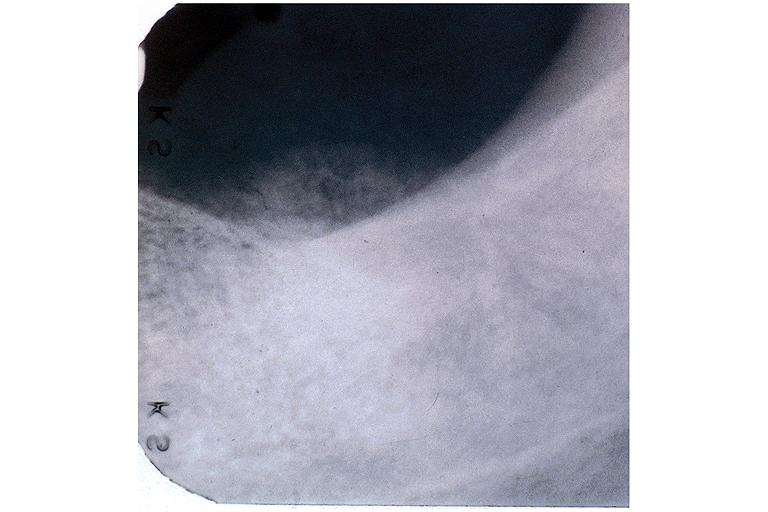s vasculitis foreign body present?
Answer the question using a single word or phrase. No 